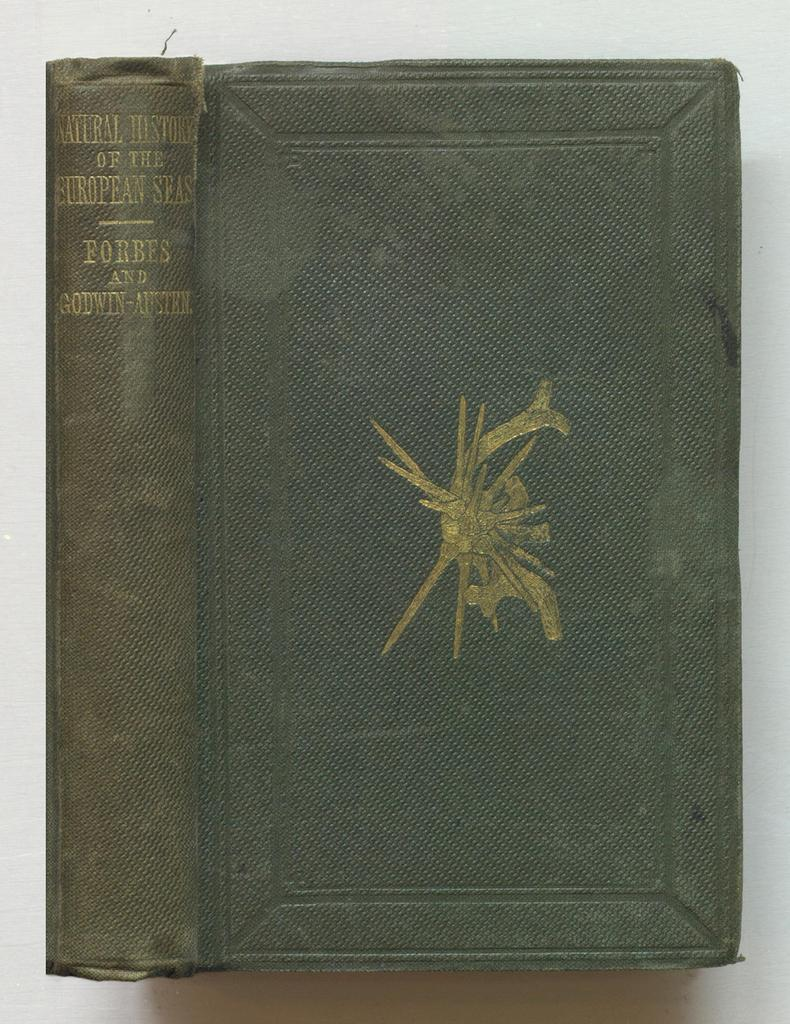<image>
Render a clear and concise summary of the photo. An old book about the history of European Seas has a golden abstract form on the cover. 